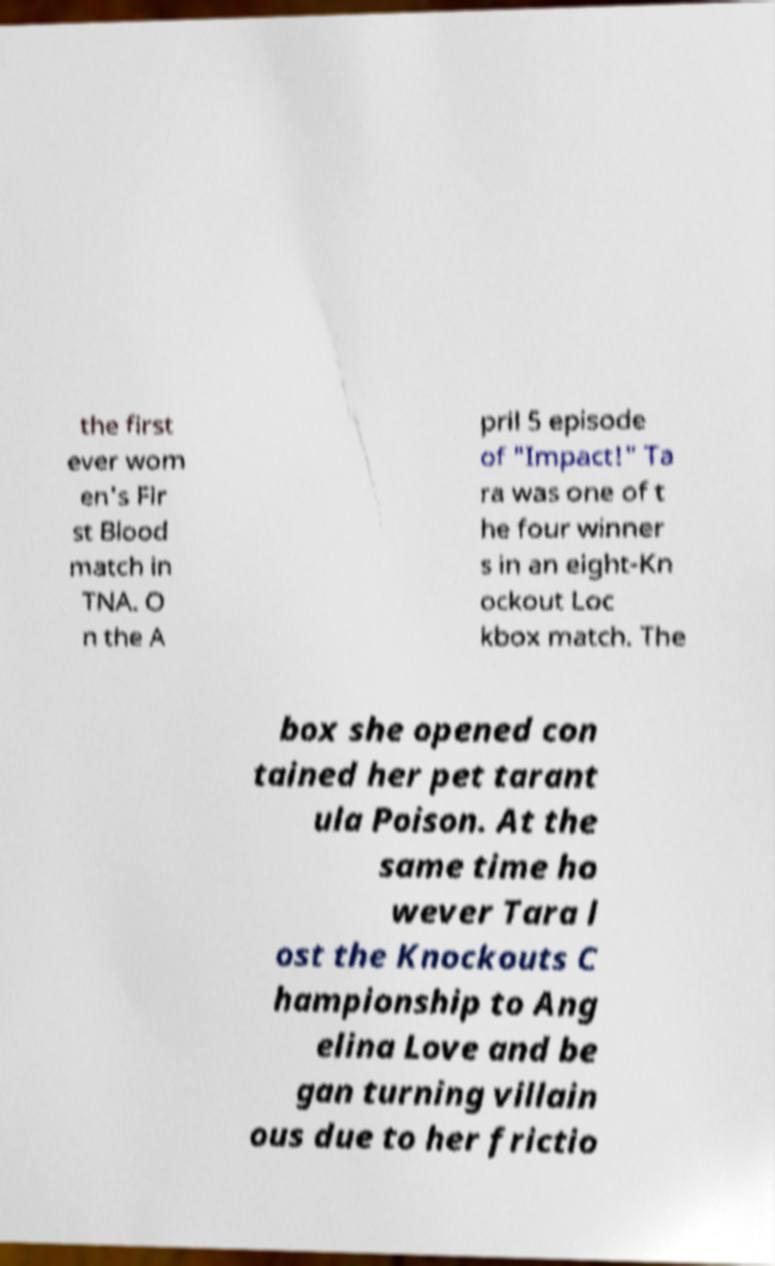Can you read and provide the text displayed in the image?This photo seems to have some interesting text. Can you extract and type it out for me? the first ever wom en's Fir st Blood match in TNA. O n the A pril 5 episode of "Impact!" Ta ra was one of t he four winner s in an eight-Kn ockout Loc kbox match. The box she opened con tained her pet tarant ula Poison. At the same time ho wever Tara l ost the Knockouts C hampionship to Ang elina Love and be gan turning villain ous due to her frictio 